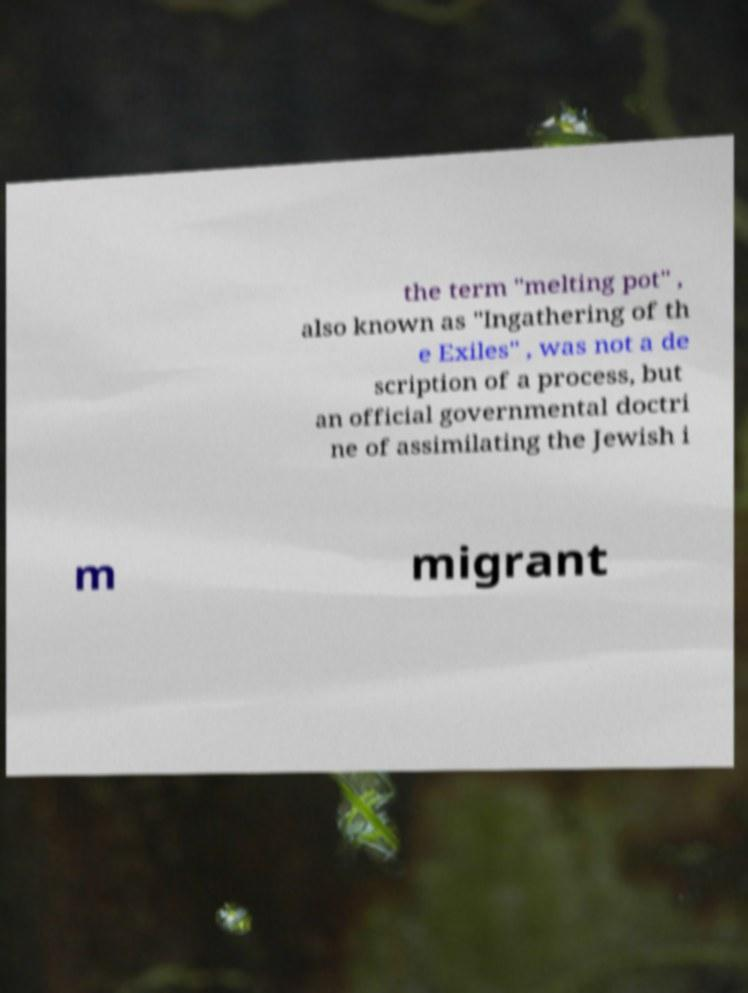I need the written content from this picture converted into text. Can you do that? the term "melting pot" , also known as "Ingathering of th e Exiles" , was not a de scription of a process, but an official governmental doctri ne of assimilating the Jewish i m migrant 